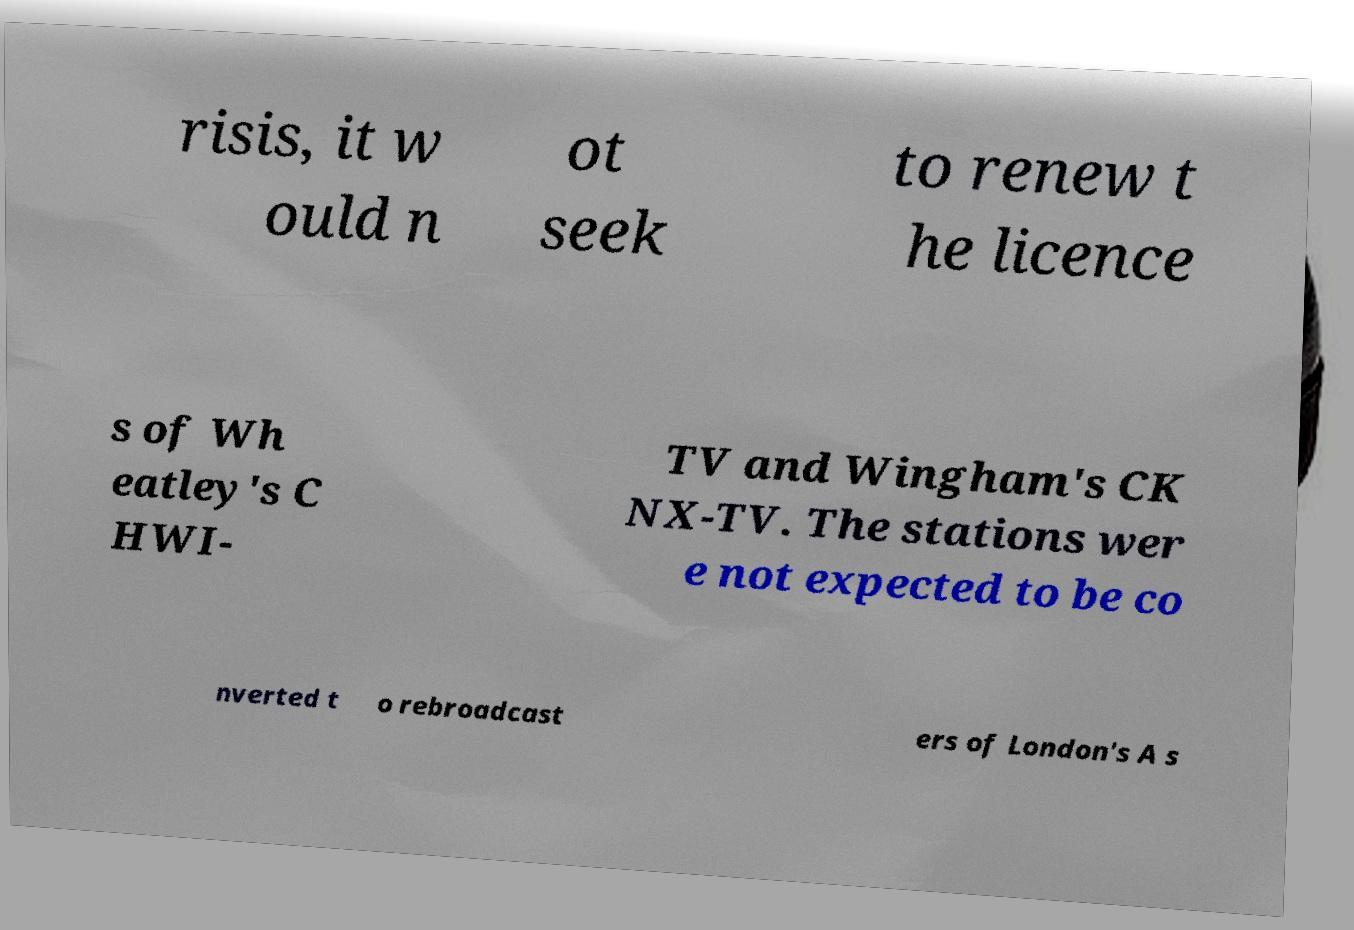Can you accurately transcribe the text from the provided image for me? risis, it w ould n ot seek to renew t he licence s of Wh eatley's C HWI- TV and Wingham's CK NX-TV. The stations wer e not expected to be co nverted t o rebroadcast ers of London's A s 